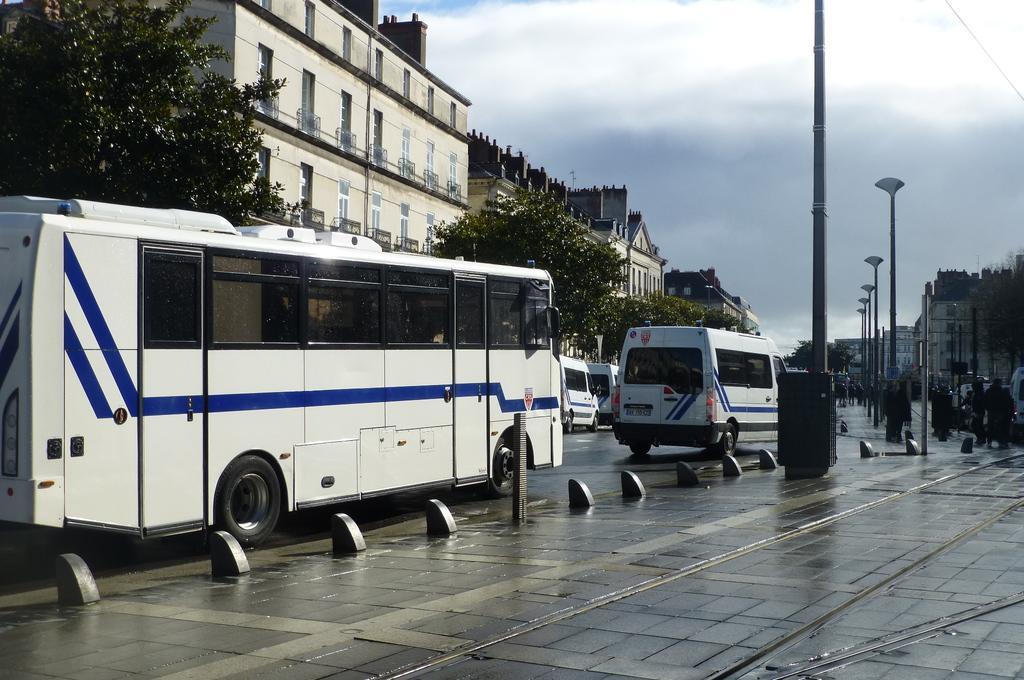Please provide a concise description of this image. In this image we can see there is a road. On the road there are some vehicles which are passing and some polls. In the either sides of the road there are buildings and trees. In the background of the image there is a sky. 